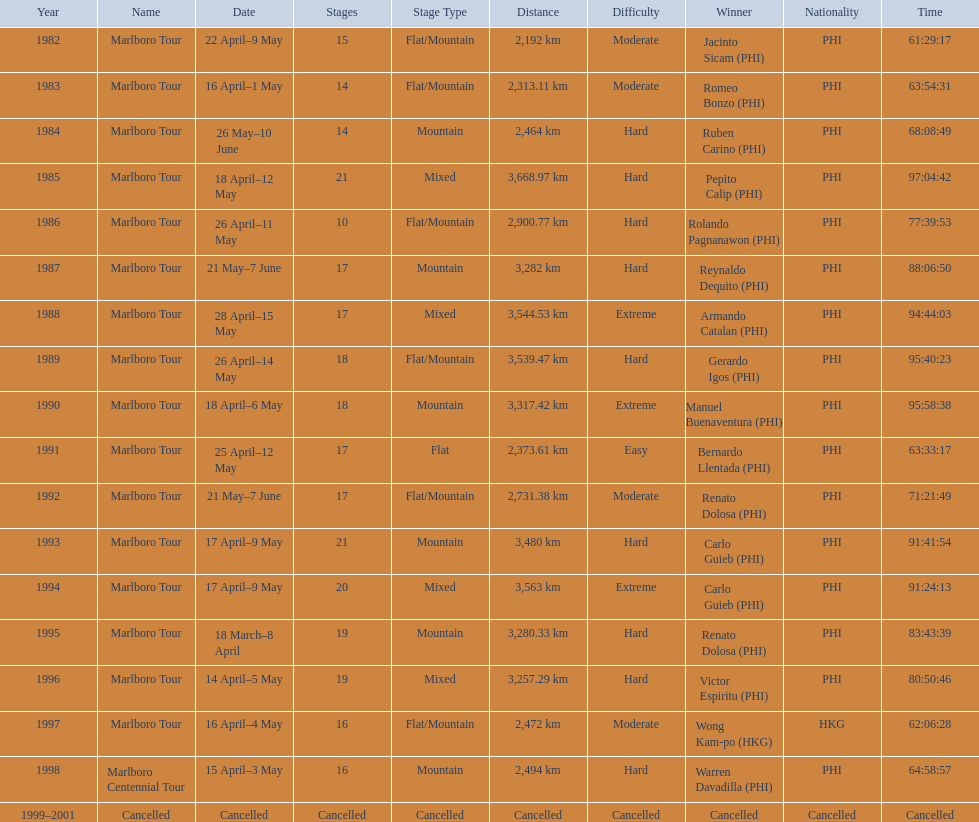What race did warren davadilla compete in in 1998? Marlboro Centennial Tour. How long did it take davadilla to complete the marlboro centennial tour? 64:58:57. Which year did warren davdilla (w.d.) appear? 1998. What tour did w.d. complete? Marlboro Centennial Tour. What is the time recorded in the same row as w.d.? 64:58:57. 